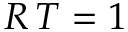Convert formula to latex. <formula><loc_0><loc_0><loc_500><loc_500>R \, T = 1</formula> 